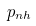Convert formula to latex. <formula><loc_0><loc_0><loc_500><loc_500>p _ { n h }</formula> 